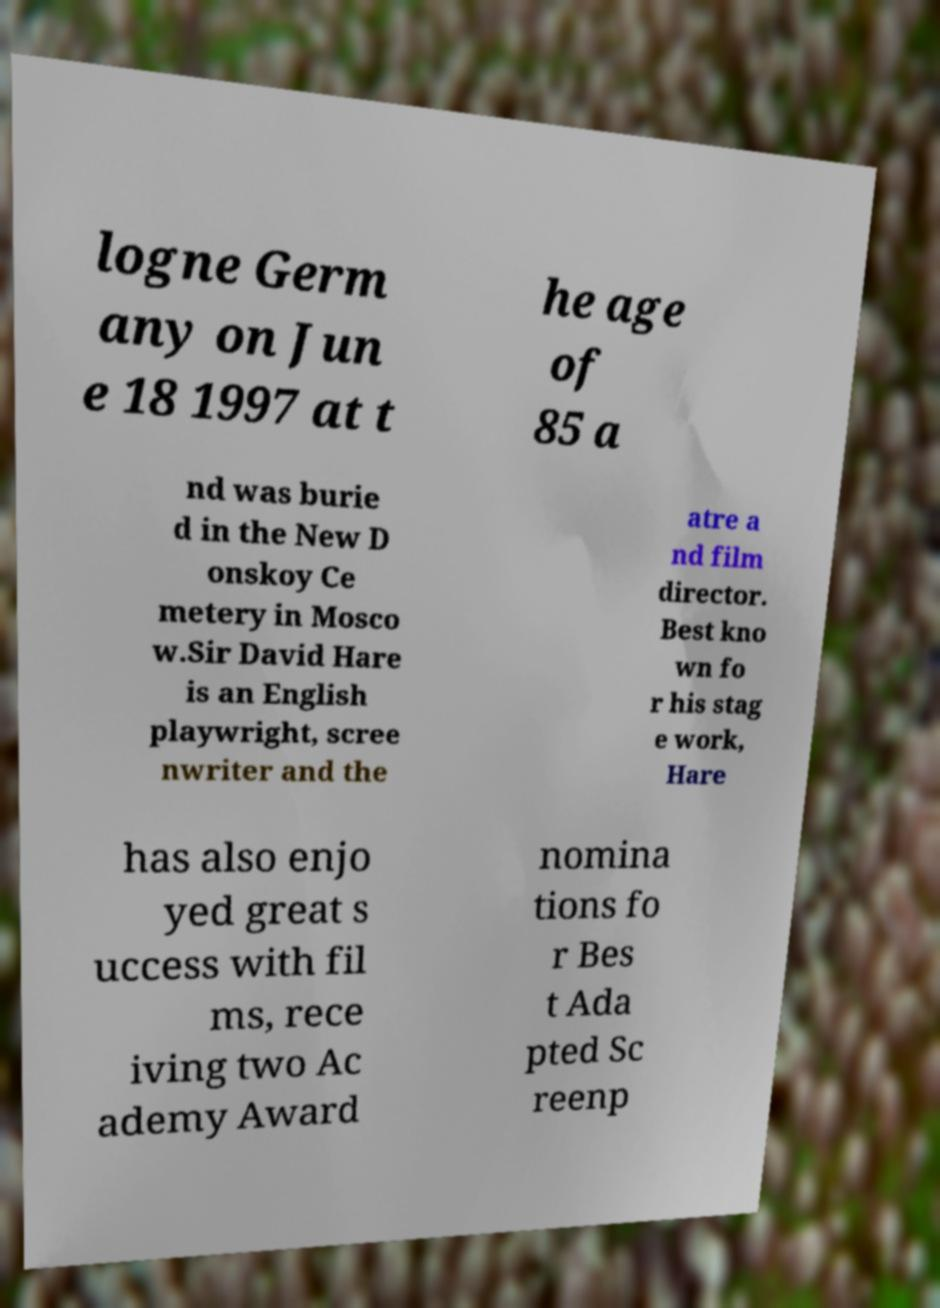For documentation purposes, I need the text within this image transcribed. Could you provide that? logne Germ any on Jun e 18 1997 at t he age of 85 a nd was burie d in the New D onskoy Ce metery in Mosco w.Sir David Hare is an English playwright, scree nwriter and the atre a nd film director. Best kno wn fo r his stag e work, Hare has also enjo yed great s uccess with fil ms, rece iving two Ac ademy Award nomina tions fo r Bes t Ada pted Sc reenp 